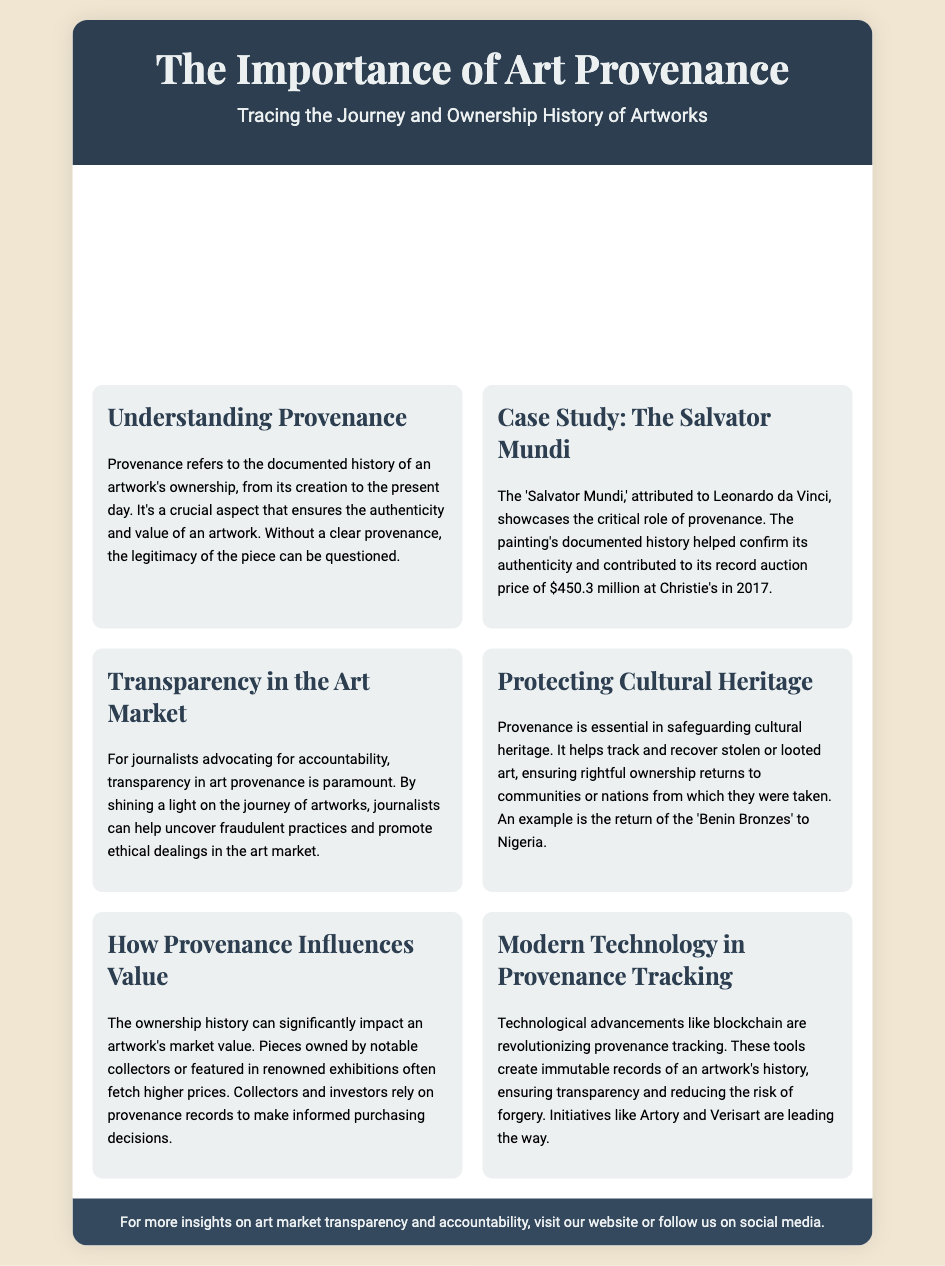What is provenance? Provenance refers to the documented history of an artwork's ownership, from its creation to the present day.
Answer: Documented history of an artwork's ownership What record auction price did the Salvator Mundi achieve? The record auction price achieved by the Salvator Mundi at Christie's in 2017 is provided in the case study section.
Answer: $450.3 million Which artwork was returned to Nigeria? The example of the artwork returned to Nigeria is mentioned under protecting cultural heritage.
Answer: Benin Bronzes What technological advancements are changing provenance tracking? The document discusses technological advancements that are revolutionizing provenance tracking.
Answer: Blockchain Why is transparency in art provenance important for journalists? The text specifies a reason why transparency in art provenance is paramount for journalists advocating for accountability.
Answer: To uncover fraudulent practices and promote ethical dealings 